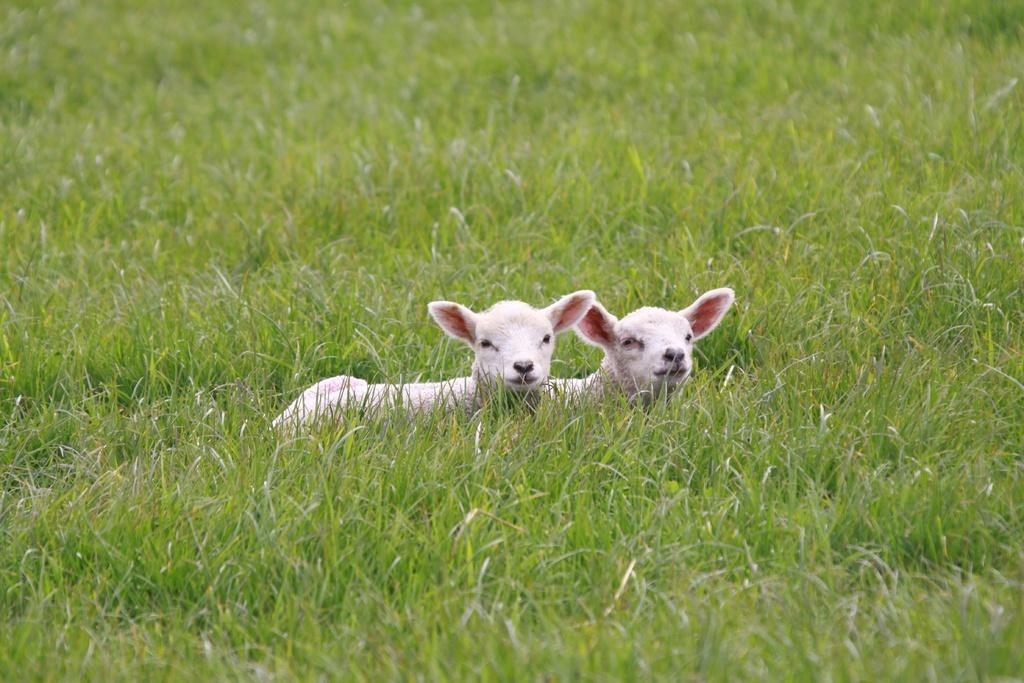What type of plants are in the image? The image contains grass plants. How many lamps are visible in the image? There are two lamps in the image. What color are the lamps? The lamps are white in color. What condition is the roof in, and who is responsible for fixing it in the image? There is no roof present in the image, so it is not possible to determine its condition or who might be responsible for fixing it. 